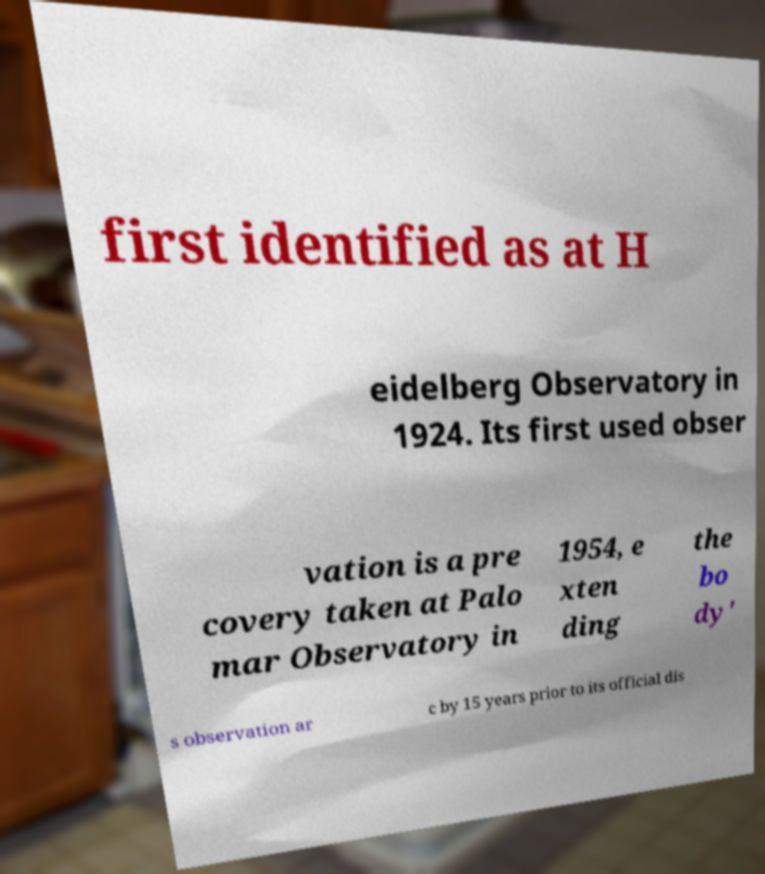Can you read and provide the text displayed in the image?This photo seems to have some interesting text. Can you extract and type it out for me? first identified as at H eidelberg Observatory in 1924. Its first used obser vation is a pre covery taken at Palo mar Observatory in 1954, e xten ding the bo dy' s observation ar c by 15 years prior to its official dis 